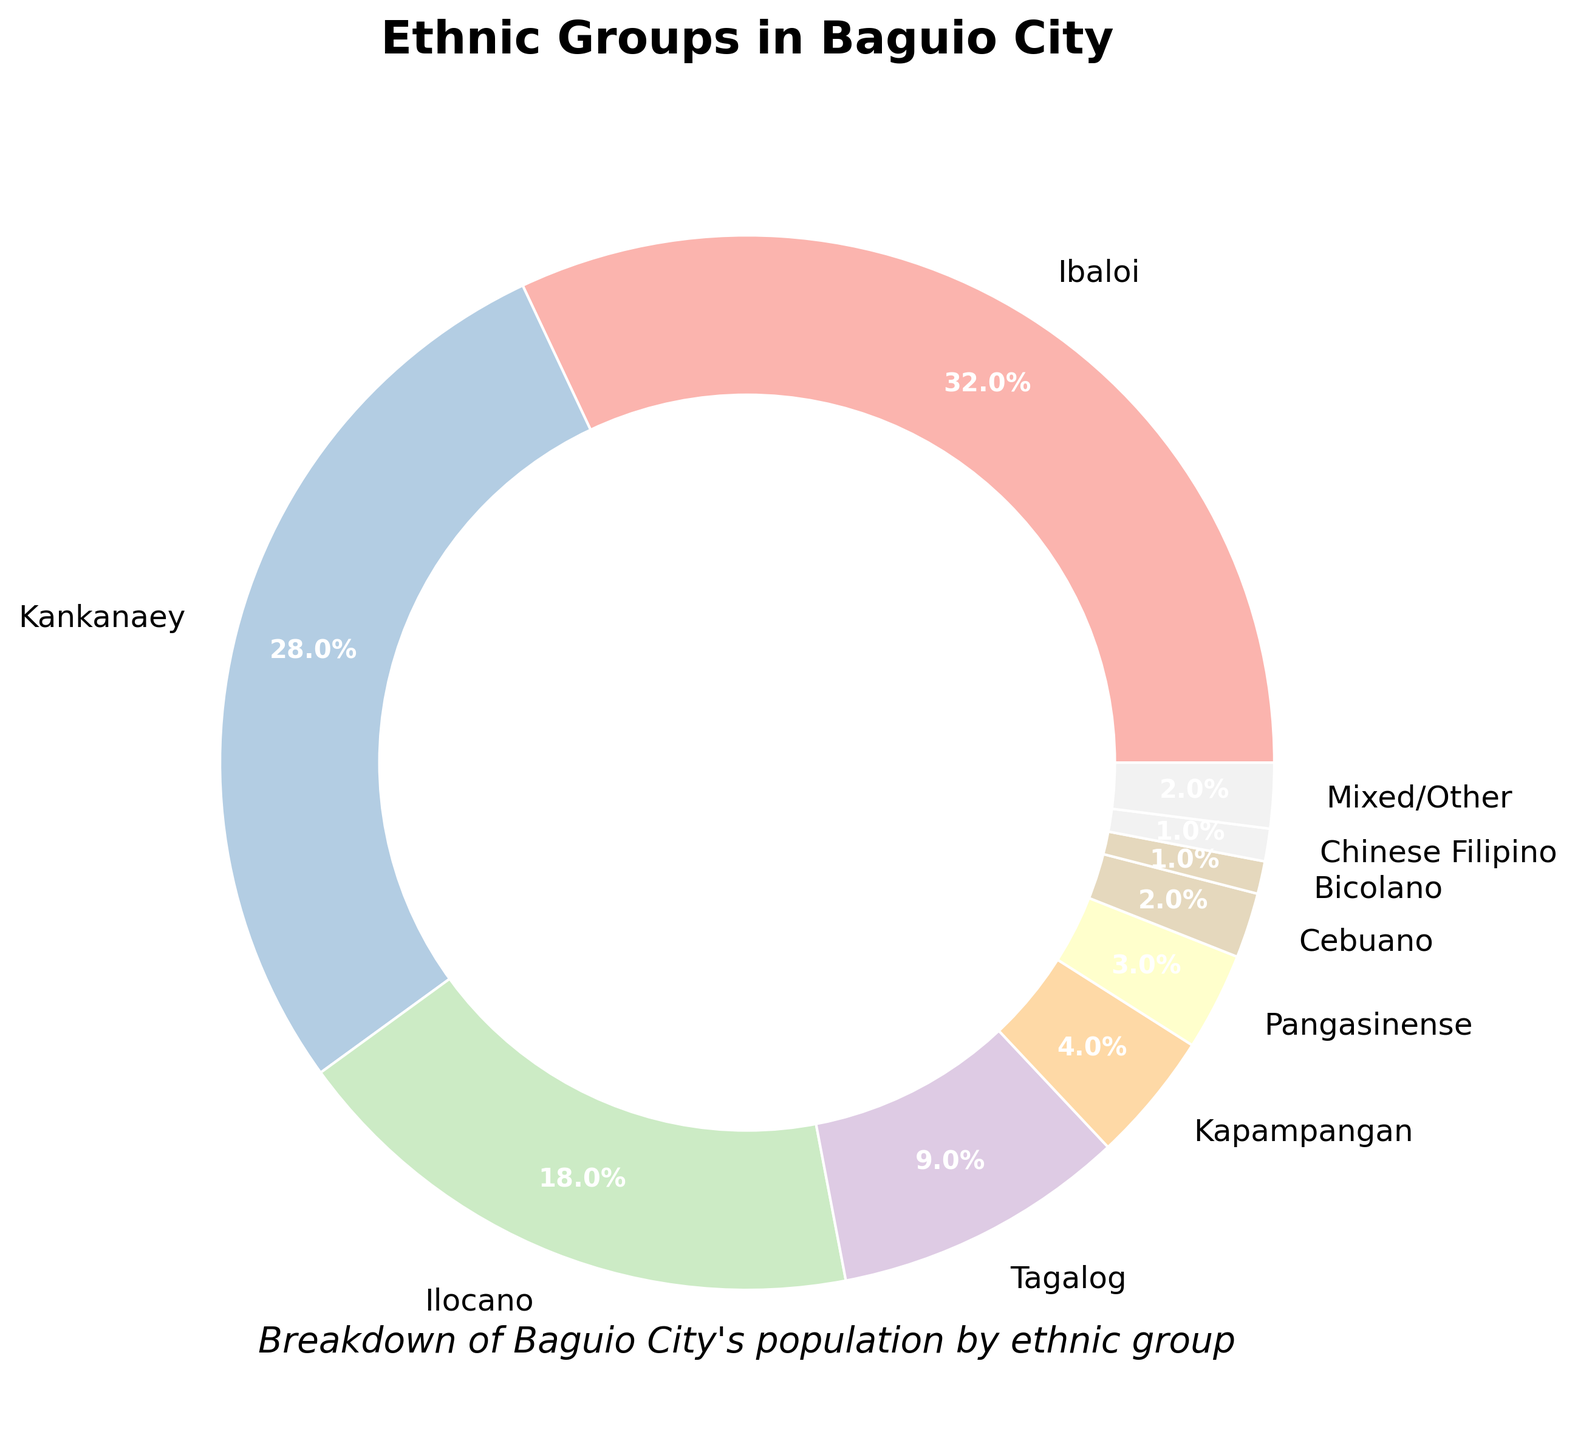What's the most represented ethnic group in Baguio City? The pie chart shows the Ibaloi group as having the largest segment, which is 32% or the largest area visually.
Answer: Ibaloi Which two ethnic groups have a nearly equal percentage of the population? The pie chart segments for the Bicolano and Chinese Filipino groups look similar. Validating, both have 1% each.
Answer: Bicolano and Chinese Filipino What is the combined percentage of the Ilocano and Tagalog groups? Looking at the pie chart, the Ilocano group has 18% and the Tagalog group has 9%. Summing these gives 18% + 9% = 27%.
Answer: 27% How much higher is the percentage of the Kankanaey group compared to the Kapampangan group? The pie chart shows the Kankanaey group has 28% and the Kapampangan group has 4%. The difference is 28% - 4% = 24%.
Answer: 24% Which ethnic group has a smaller population percentage than the Tagalog group but larger than the Pangasinense group? From the pie chart, the Tagalog group has 9% and the Pangasinense group has 3%. The Kapampangan group, with 4%, fits this criteria.
Answer: Kapampangan If you sum up the percentages of the Kankanaey, Ilocano, and Tagalog groups, what do you get? The pie chart shows Kankanaey with 28%, Ilocano with 18%, and Tagalog with 9%. Summing these yields 28% + 18% + 9% = 55%.
Answer: 55% Which group has the least representation in the chart? Examining the pie chart, the smallest segment belongs to Bicolano and Chinese Filipino, each at 1%.
Answer: Bicolano, Chinese Filipino What is the difference in percentage between the Ibaloi and Tagalog groups? The pie chart shows Ibaloi at 32% and Tagalog at 9%. The difference is 32% - 9% = 23%.
Answer: 23% What percentage of the population is represented by groups with 2% or less? The groups are Cebuano (2%), Bicolano (1%), Chinese Filipino (1%), Mixed/Other (2%). Summing these gives 2% + 1% + 1% + 2% = 6%.
Answer: 6% Which ethnic group occupies the second-largest segment in the pie chart? The pie chart shows the Ibaloi group as the largest, and the Kankanaey group as the second-largest with 28%.
Answer: Kankanaey 